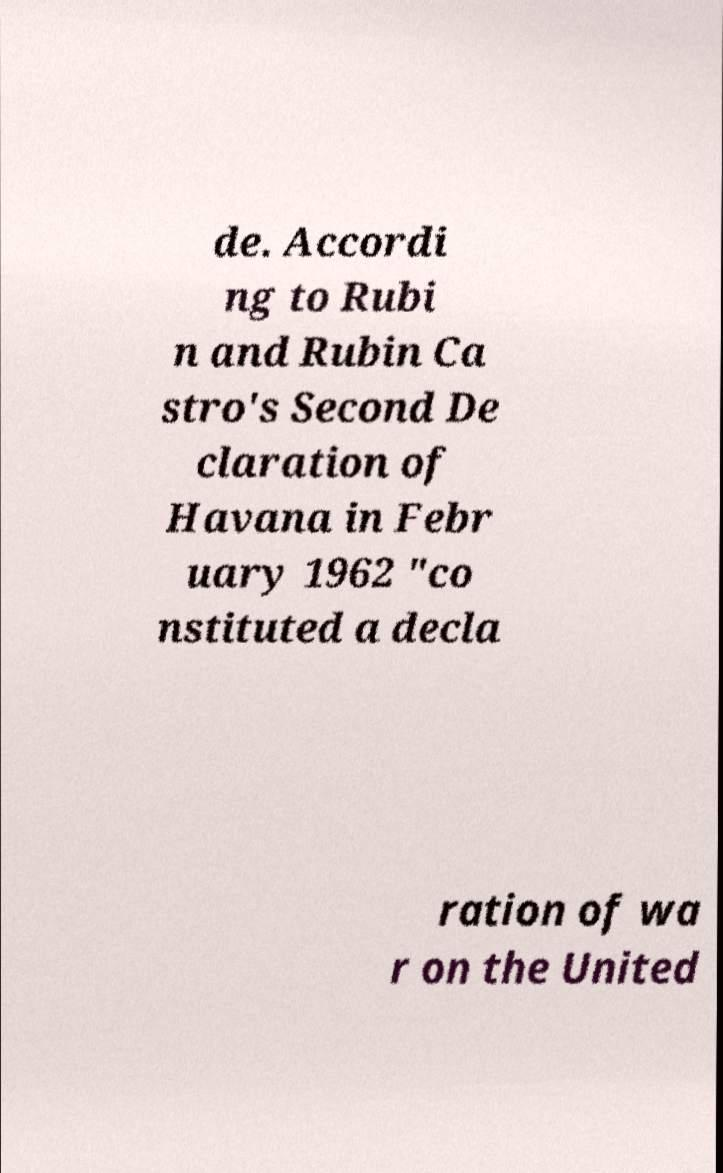I need the written content from this picture converted into text. Can you do that? de. Accordi ng to Rubi n and Rubin Ca stro's Second De claration of Havana in Febr uary 1962 "co nstituted a decla ration of wa r on the United 